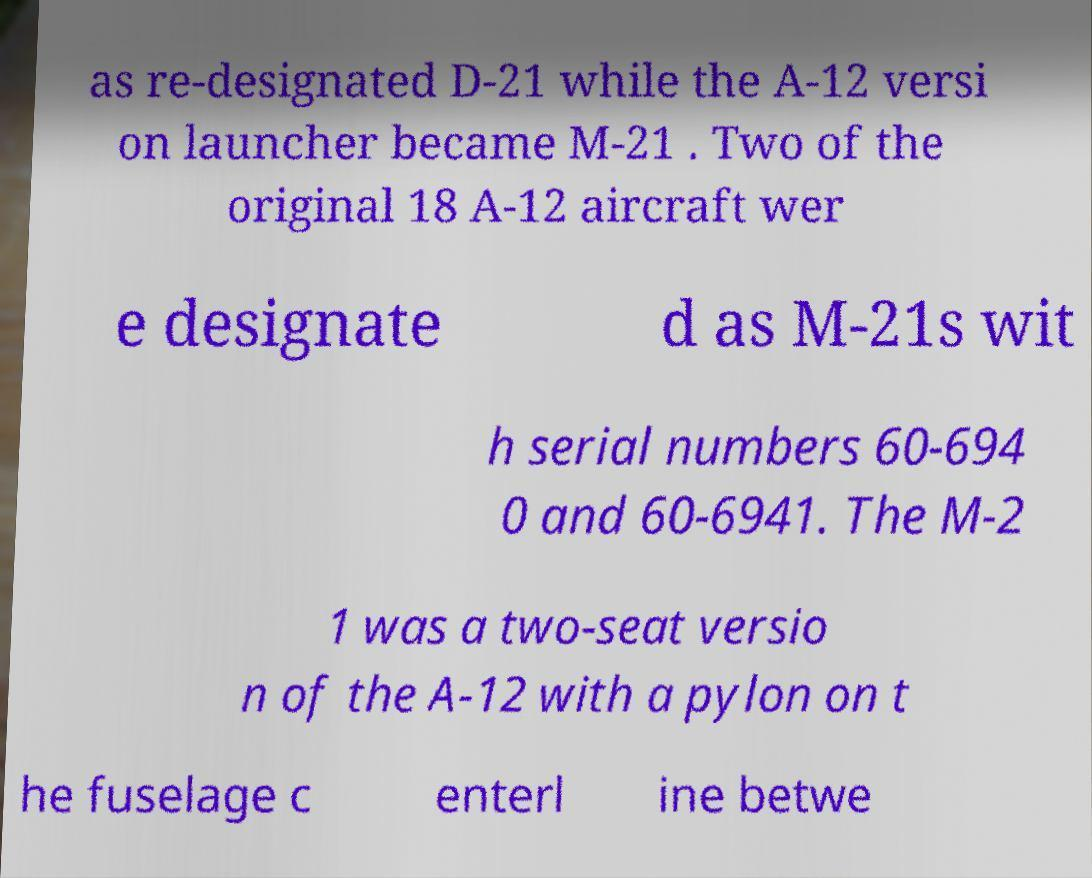What messages or text are displayed in this image? I need them in a readable, typed format. as re-designated D-21 while the A-12 versi on launcher became M-21 . Two of the original 18 A-12 aircraft wer e designate d as M-21s wit h serial numbers 60-694 0 and 60-6941. The M-2 1 was a two-seat versio n of the A-12 with a pylon on t he fuselage c enterl ine betwe 